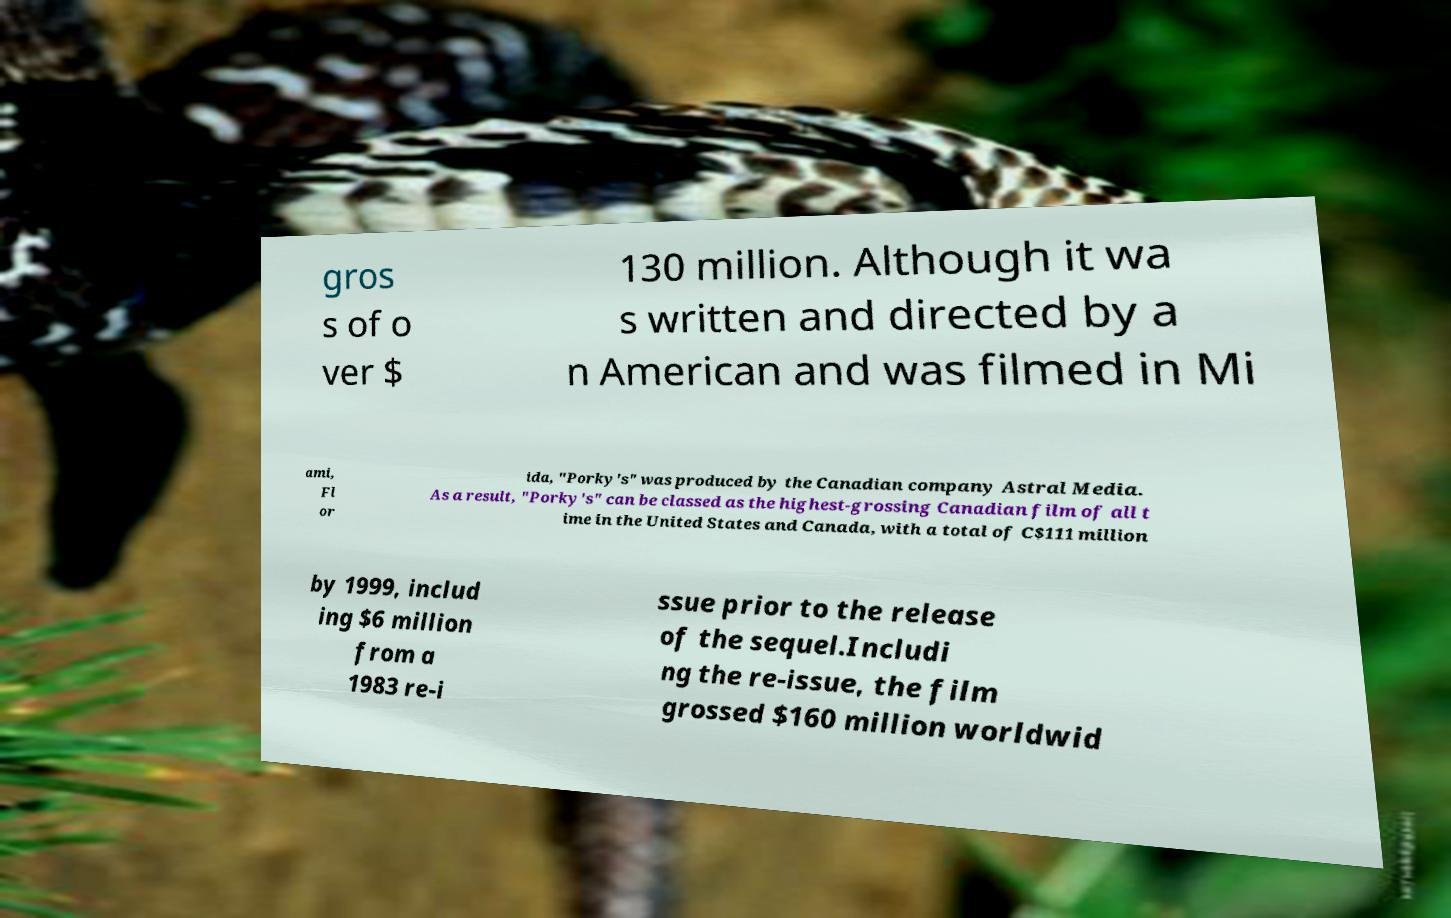There's text embedded in this image that I need extracted. Can you transcribe it verbatim? gros s of o ver $ 130 million. Although it wa s written and directed by a n American and was filmed in Mi ami, Fl or ida, "Porky's" was produced by the Canadian company Astral Media. As a result, "Porky's" can be classed as the highest-grossing Canadian film of all t ime in the United States and Canada, with a total of C$111 million by 1999, includ ing $6 million from a 1983 re-i ssue prior to the release of the sequel.Includi ng the re-issue, the film grossed $160 million worldwid 